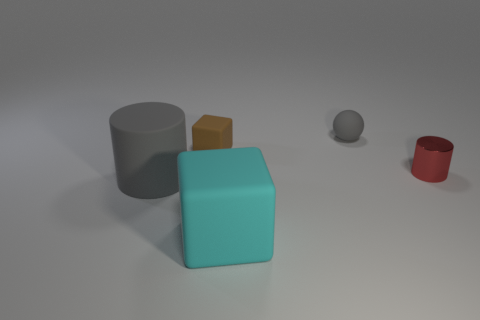What number of things are cylinders or gray rubber things in front of the red cylinder? There is one gray cylinder located towards the left in the image. In front of the red cylinder, there are no objects. Therefore, combining the gray cylinder and the absence of other qualifying objects in front of the red cylinder, the answer is one. 